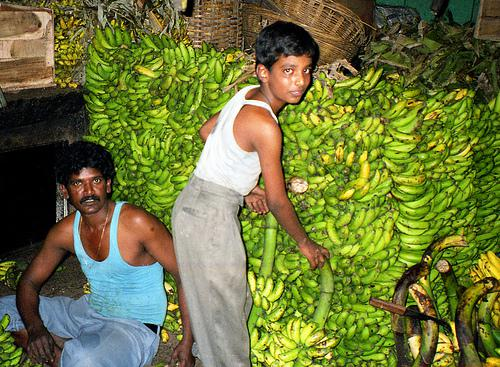Question: what fruit is depicted in this picture?
Choices:
A. Banana.
B. Strawberry.
C. Kiwi.
D. Apple.
Answer with the letter. Answer: A Question: how many animals are shown?
Choices:
A. Zero.
B. Two.
C. Three.
D. Six.
Answer with the letter. Answer: A Question: who are the people in the picture looking at?
Choices:
A. Ducks.
B. Cameraman.
C. Sun.
D. Rainbow.
Answer with the letter. Answer: B Question: what time of day is this picture taken?
Choices:
A. Nighttime.
B. Morning.
C. Afternoon.
D. Dusk.
Answer with the letter. Answer: A 